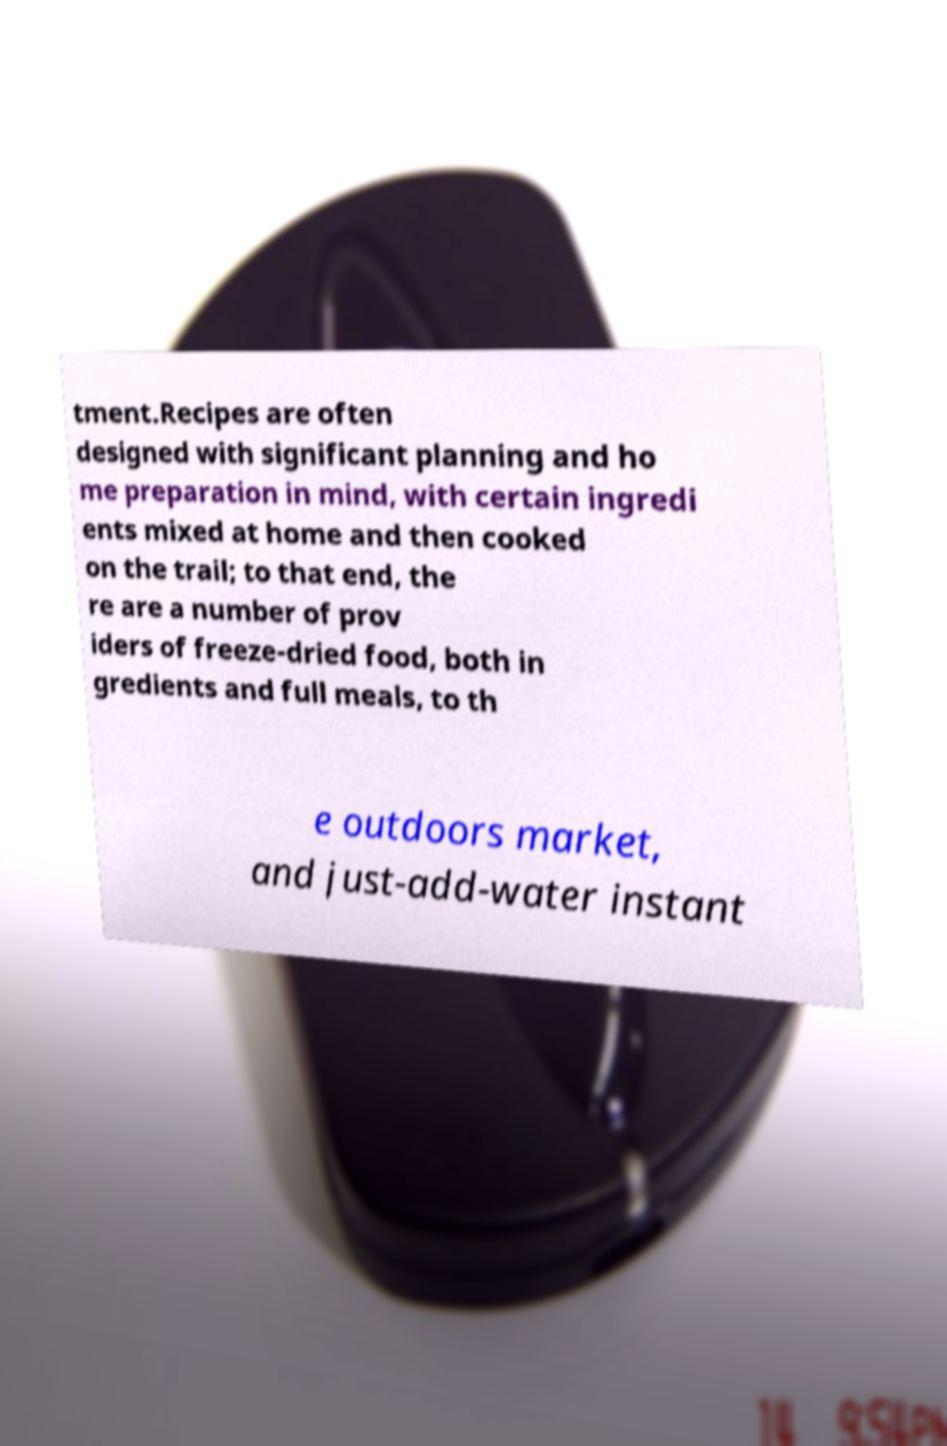Can you accurately transcribe the text from the provided image for me? tment.Recipes are often designed with significant planning and ho me preparation in mind, with certain ingredi ents mixed at home and then cooked on the trail; to that end, the re are a number of prov iders of freeze-dried food, both in gredients and full meals, to th e outdoors market, and just-add-water instant 